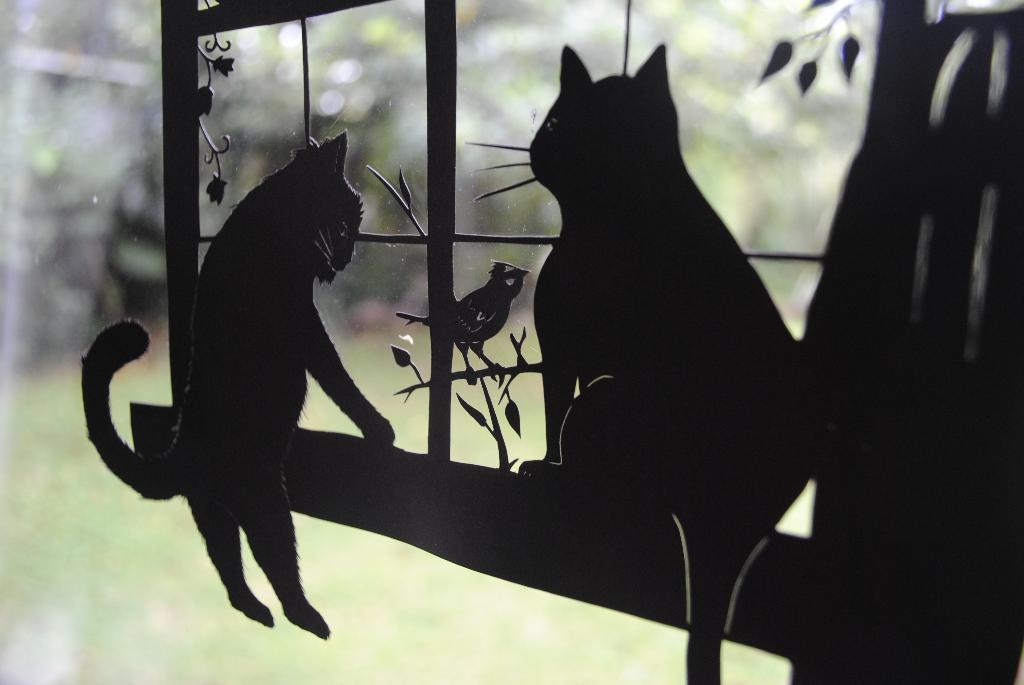What type of door is visible in the image? There is a glass door in the image. What kind of shadows can be seen in the image? The shadow of cats, a bird, and a plant are visible in the image. How would you describe the background of the image? The background of the image is blurry. What type of grape is being used to celebrate the birthday in the image? There is no grape or birthday celebration present in the image. How does the fear of the cats affect the bird in the image? There is no fear or interaction between the cats and the bird in the image, as they are only represented by their shadows. 